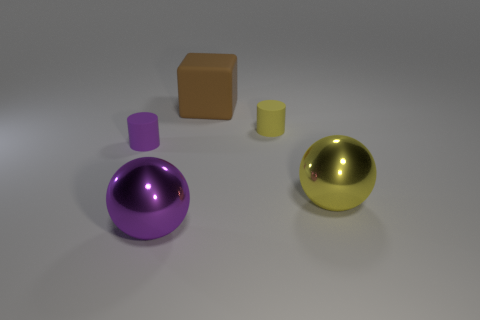Could you guess the purpose of this arrangement if it were part of a scene or story? This arrangement might be part of a puzzle or a teaching tool about geometry and materials. The collection of shapes in different colors and materials could serve as an educational set to demonstrate properties like volume, surface area, and reflectivity. Alternatively, if part of a narrative, these objects could be symbolic, perhaps representing different elements or characters in a minimalist portrayal. 